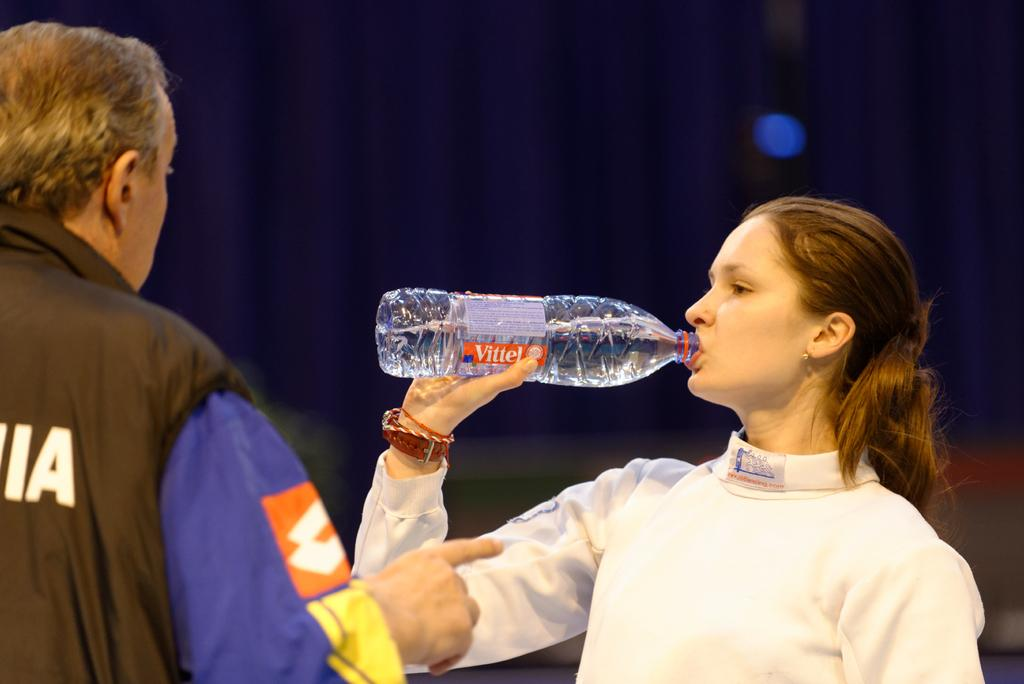<image>
Offer a succinct explanation of the picture presented. A woman talks to a man while drinking Vittel water 